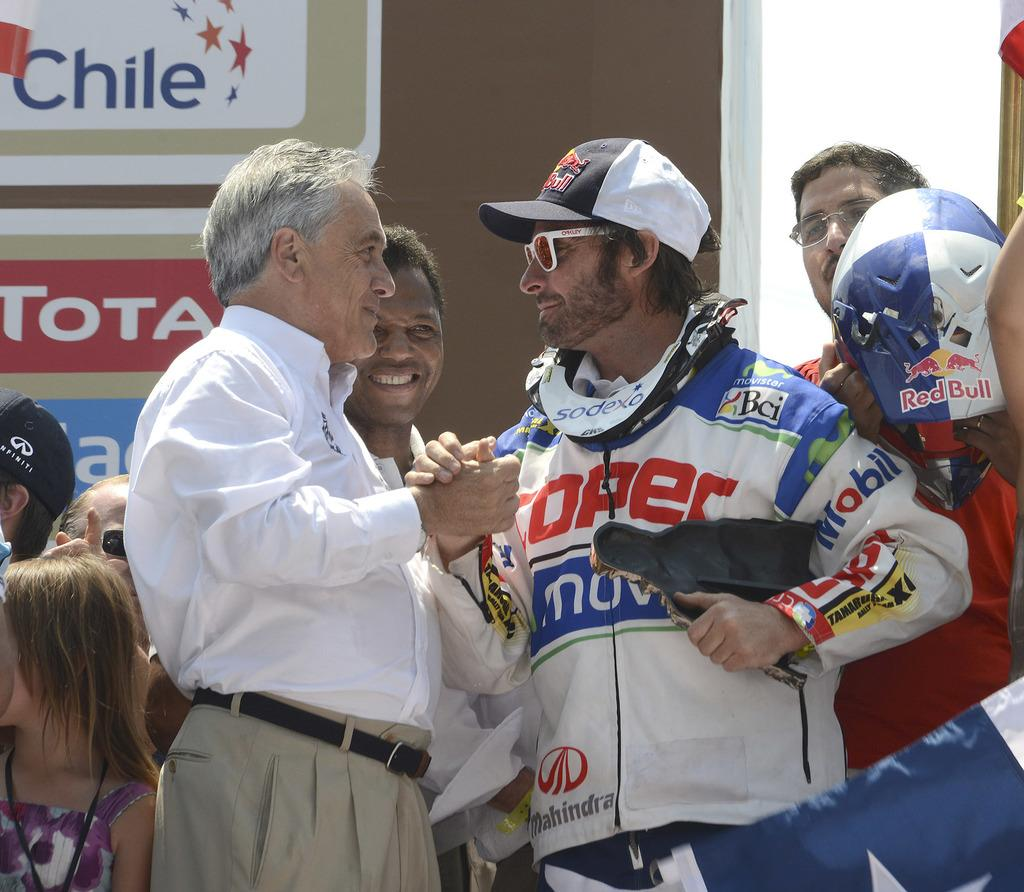<image>
Offer a succinct explanation of the picture presented. a man that is wearing a Toper jacket on his back 